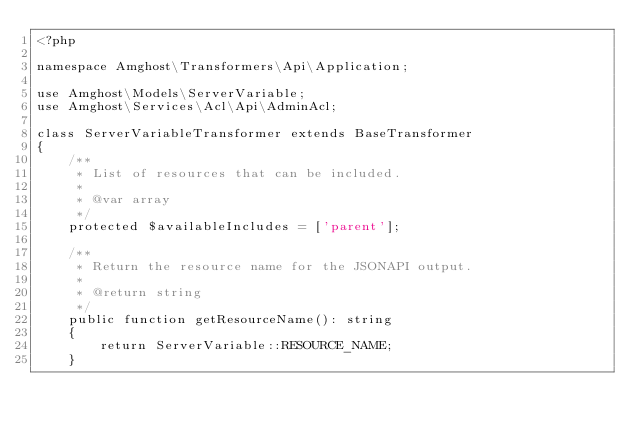<code> <loc_0><loc_0><loc_500><loc_500><_PHP_><?php

namespace Amghost\Transformers\Api\Application;

use Amghost\Models\ServerVariable;
use Amghost\Services\Acl\Api\AdminAcl;

class ServerVariableTransformer extends BaseTransformer
{
    /**
     * List of resources that can be included.
     *
     * @var array
     */
    protected $availableIncludes = ['parent'];

    /**
     * Return the resource name for the JSONAPI output.
     *
     * @return string
     */
    public function getResourceName(): string
    {
        return ServerVariable::RESOURCE_NAME;
    }
</code> 